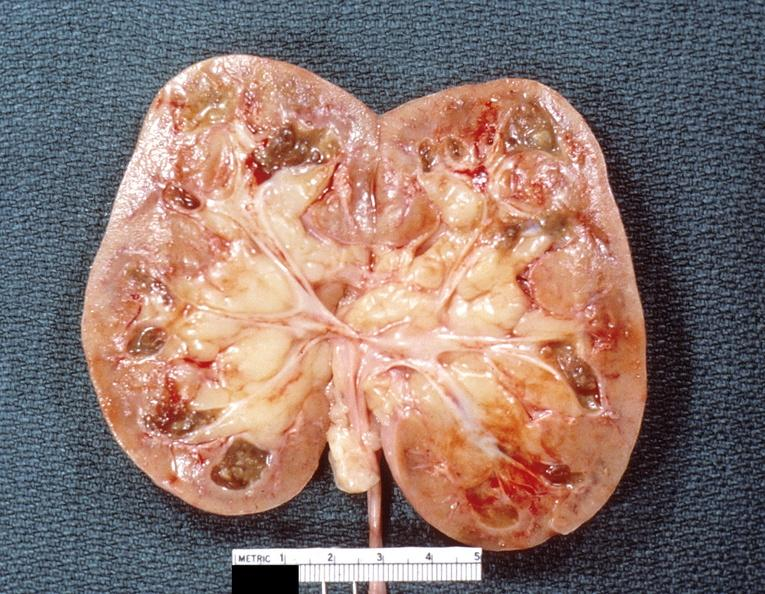does lesion cross show kidney, renal papillary necrosis, subacute?
Answer the question using a single word or phrase. No 